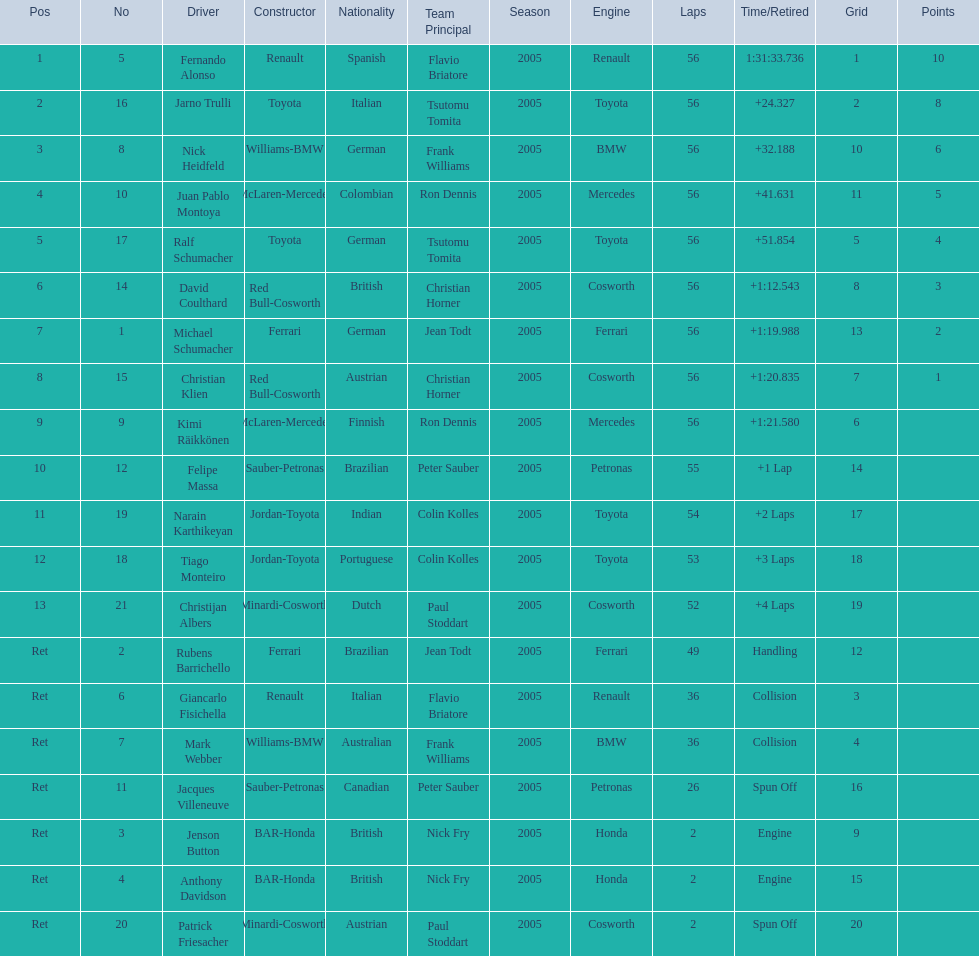How many drivers were retired before the race could end? 7. 